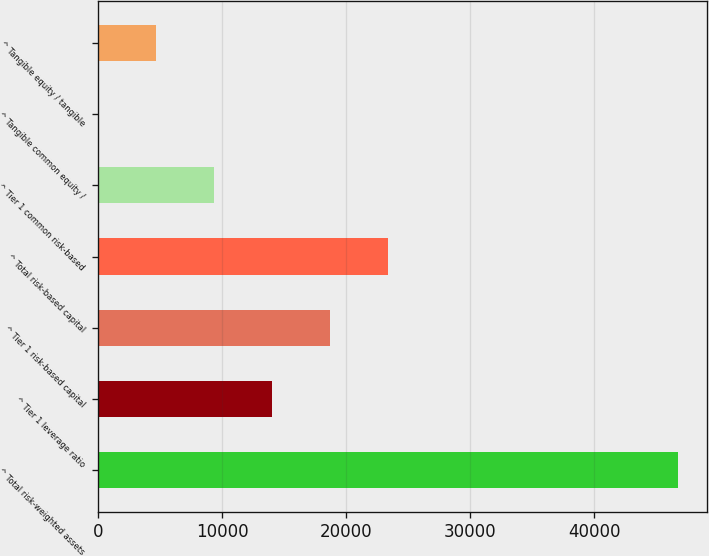<chart> <loc_0><loc_0><loc_500><loc_500><bar_chart><fcel>^ Total risk-weighted assets<fcel>^ Tier 1 leverage ratio<fcel>^ Tier 1 risk-based capital<fcel>^ Total risk-based capital<fcel>^ Tier 1 common risk-based<fcel>^ Tangible common equity /<fcel>^ Tangible equity / tangible<nl><fcel>46716<fcel>14020.6<fcel>18691.4<fcel>23362.2<fcel>9349.87<fcel>8.33<fcel>4679.1<nl></chart> 